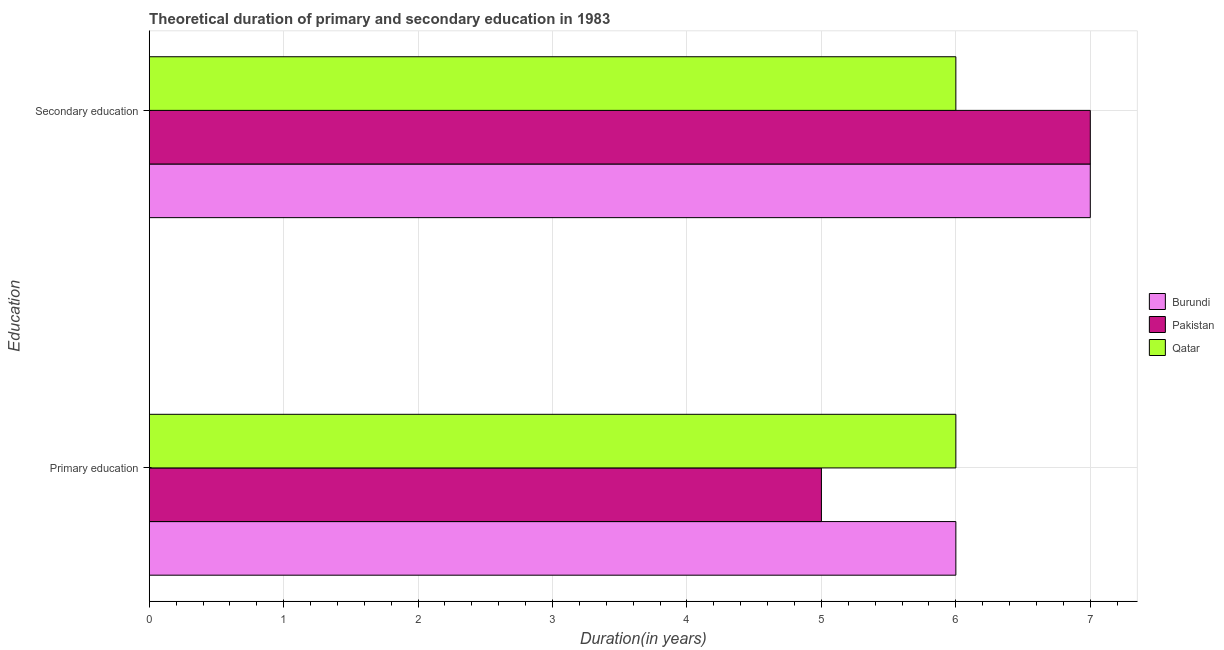What is the label of the 1st group of bars from the top?
Offer a terse response. Secondary education. What is the duration of primary education in Qatar?
Your answer should be very brief. 6. Across all countries, what is the maximum duration of secondary education?
Your response must be concise. 7. In which country was the duration of primary education maximum?
Provide a short and direct response. Burundi. In which country was the duration of primary education minimum?
Give a very brief answer. Pakistan. What is the total duration of primary education in the graph?
Provide a succinct answer. 17. What is the difference between the duration of secondary education in Pakistan and that in Burundi?
Your response must be concise. 0. What is the difference between the duration of primary education in Qatar and the duration of secondary education in Pakistan?
Your answer should be very brief. -1. What is the average duration of primary education per country?
Offer a terse response. 5.67. What is the difference between the duration of primary education and duration of secondary education in Qatar?
Give a very brief answer. 0. In how many countries, is the duration of primary education greater than 0.2 years?
Keep it short and to the point. 3. Is the duration of secondary education in Pakistan less than that in Burundi?
Make the answer very short. No. In how many countries, is the duration of primary education greater than the average duration of primary education taken over all countries?
Offer a terse response. 2. What does the 3rd bar from the top in Primary education represents?
Ensure brevity in your answer.  Burundi. How many bars are there?
Your response must be concise. 6. How many countries are there in the graph?
Offer a very short reply. 3. What is the difference between two consecutive major ticks on the X-axis?
Your answer should be very brief. 1. Does the graph contain grids?
Your answer should be compact. Yes. Where does the legend appear in the graph?
Keep it short and to the point. Center right. How are the legend labels stacked?
Keep it short and to the point. Vertical. What is the title of the graph?
Provide a short and direct response. Theoretical duration of primary and secondary education in 1983. Does "Czech Republic" appear as one of the legend labels in the graph?
Your response must be concise. No. What is the label or title of the X-axis?
Give a very brief answer. Duration(in years). What is the label or title of the Y-axis?
Offer a very short reply. Education. What is the Duration(in years) in Qatar in Primary education?
Make the answer very short. 6. What is the Duration(in years) of Burundi in Secondary education?
Keep it short and to the point. 7. What is the Duration(in years) in Pakistan in Secondary education?
Offer a very short reply. 7. What is the Duration(in years) in Qatar in Secondary education?
Give a very brief answer. 6. Across all Education, what is the maximum Duration(in years) of Pakistan?
Your response must be concise. 7. Across all Education, what is the minimum Duration(in years) in Pakistan?
Offer a very short reply. 5. Across all Education, what is the minimum Duration(in years) in Qatar?
Your answer should be very brief. 6. What is the total Duration(in years) in Burundi in the graph?
Ensure brevity in your answer.  13. What is the total Duration(in years) of Qatar in the graph?
Ensure brevity in your answer.  12. What is the difference between the Duration(in years) of Burundi in Primary education and that in Secondary education?
Ensure brevity in your answer.  -1. What is the difference between the Duration(in years) in Pakistan in Primary education and that in Secondary education?
Make the answer very short. -2. What is the difference between the Duration(in years) in Burundi in Primary education and the Duration(in years) in Qatar in Secondary education?
Offer a very short reply. 0. What is the average Duration(in years) in Burundi per Education?
Keep it short and to the point. 6.5. What is the average Duration(in years) of Qatar per Education?
Your answer should be compact. 6. What is the difference between the Duration(in years) in Burundi and Duration(in years) in Qatar in Primary education?
Ensure brevity in your answer.  0. What is the difference between the Duration(in years) of Burundi and Duration(in years) of Pakistan in Secondary education?
Provide a succinct answer. 0. What is the difference between the Duration(in years) of Burundi and Duration(in years) of Qatar in Secondary education?
Ensure brevity in your answer.  1. What is the ratio of the Duration(in years) in Pakistan in Primary education to that in Secondary education?
Provide a succinct answer. 0.71. What is the ratio of the Duration(in years) of Qatar in Primary education to that in Secondary education?
Your answer should be compact. 1. What is the difference between the highest and the lowest Duration(in years) of Burundi?
Keep it short and to the point. 1. 